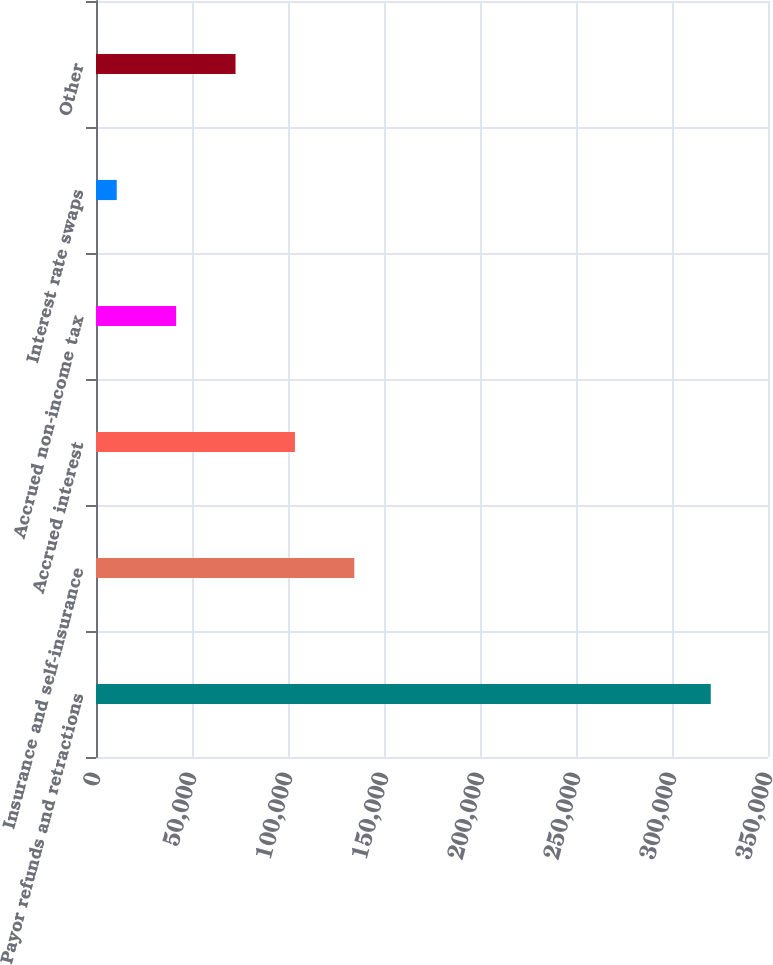Convert chart. <chart><loc_0><loc_0><loc_500><loc_500><bar_chart><fcel>Payor refunds and retractions<fcel>Insurance and self-insurance<fcel>Accrued interest<fcel>Accrued non-income tax<fcel>Interest rate swaps<fcel>Other<nl><fcel>320187<fcel>134550<fcel>103610<fcel>41731.5<fcel>10792<fcel>72671<nl></chart> 